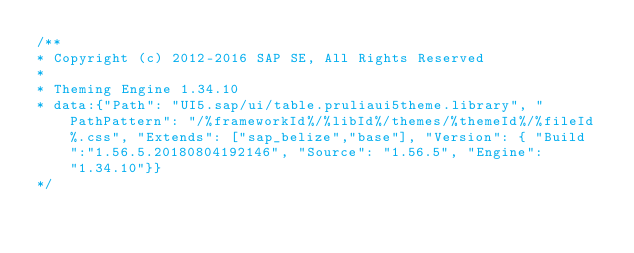Convert code to text. <code><loc_0><loc_0><loc_500><loc_500><_CSS_>/**
* Copyright (c) 2012-2016 SAP SE, All Rights Reserved
*
* Theming Engine 1.34.10
* data:{"Path": "UI5.sap/ui/table.pruliaui5theme.library", "PathPattern": "/%frameworkId%/%libId%/themes/%themeId%/%fileId%.css", "Extends": ["sap_belize","base"], "Version": { "Build":"1.56.5.20180804192146", "Source": "1.56.5", "Engine": "1.34.10"}}
*/
</code> 